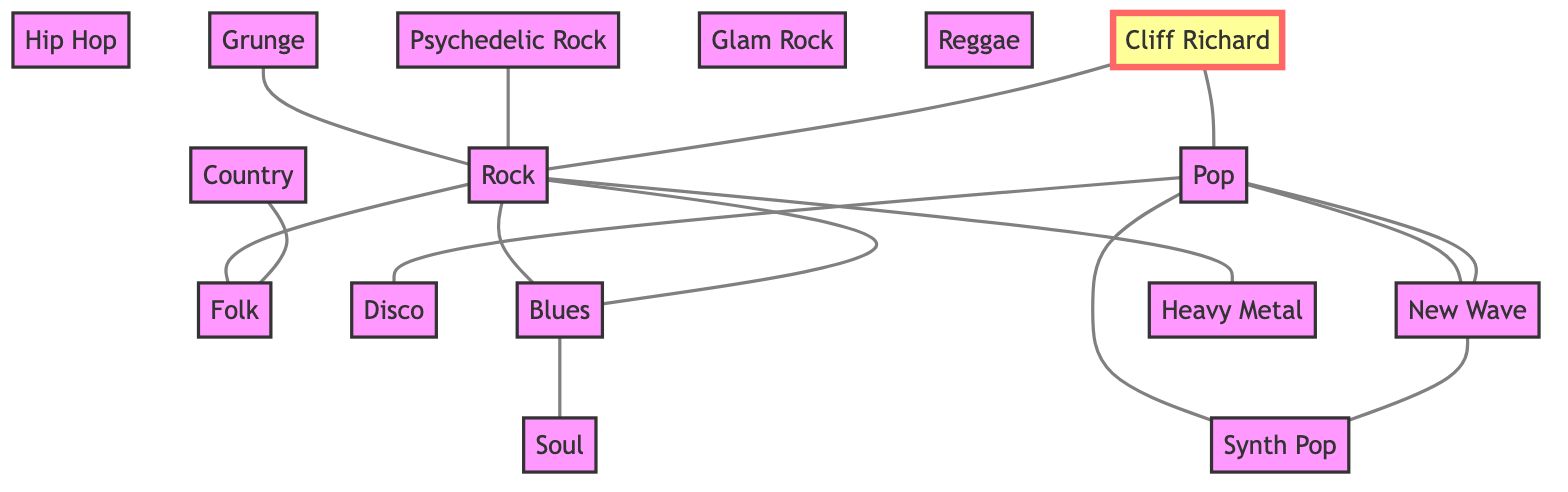What genres are connected to Rock? In the diagram, Rock has edges leading to three genres: Folk, Blues, and Heavy Metal. These represent the musical genres that are directly connected to Rock.
Answer: Folk, Blues, Heavy Metal How many nodes are present in the diagram? The total number of nodes is counted in the diagram. There are 15 unique nodes listed representing different music genres.
Answer: 15 Which genre is uniquely connected to Cliff Richard? Cliff Richard is connected to two genres: Pop and Rock. However, since the question asks for the genre uniquely associated with him, it would be Pop, as he represents a notable Pop figure in the music scene.
Answer: Pop What is the relationship between Blues and Soul? The diagram shows that Blues is connected to Soul, indicating a direct relationship between these two genres. This connection implies that elements of Blues influence Soul music.
Answer: Connected Which genre has the most connections? Analyzing the diagram, the Rock genre has the most outgoing edges, connecting it to Folk, Blues, and Heavy Metal. This shows Rock's central role in associating with multiple other genres.
Answer: Rock How many genres are connected to Pop? From the diagram, Pop is connected to three genres: New Wave, Synth Pop, and Disco. This indicates Pop's influence and relationships with multiple sub-genres.
Answer: 3 Which genre connects both Hip Hop and Funk? The relationship between Hip Hop and Funk is shown through a direct connection where Hip Hop is linked to Funk. This establishes Funk as a shared connection between them.
Answer: Funk Identify a genre that is peripheral to Rock. In the context of the diagram, Country is peripheral to Rock as it does not have a direct connection to Rock unlike other genres like Folk and Blues.
Answer: Country 